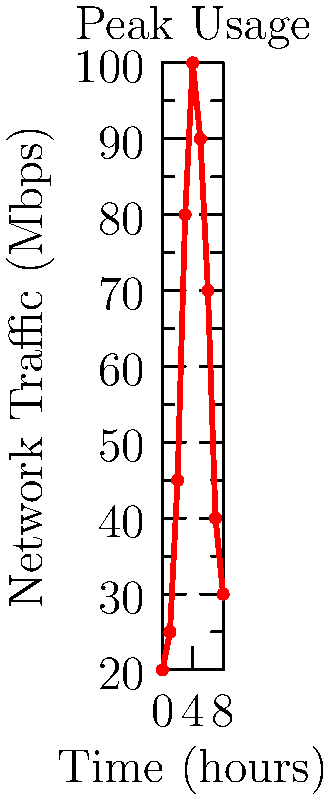Based on the network traffic flow chart for Moodle usage, at which hour does the peak traffic occur, and what strategy would you implement to optimize Moodle's performance during this time? To answer this question, let's analyze the graph step-by-step:

1. Observe the x-axis: It represents time in hours, from 0 to 8.
2. Observe the y-axis: It represents network traffic in Mbps.
3. Analyze the curve: The traffic increases from the start, reaches a peak, and then decreases.
4. Identify the peak: The highest point on the curve occurs at x = 4 (4 hours from the start) and y ≈ 100 Mbps.

Now, to optimize Moodle's performance during this peak time:

1. Implement load balancing: Distribute incoming traffic across multiple servers to prevent any single server from becoming overwhelmed.
2. Use caching mechanisms: Implement server-side and client-side caching to reduce the load on the database and improve response times.
3. Optimize database queries: Ensure that all database queries are efficient and properly indexed to handle the increased load.
4. Content Delivery Network (CDN): Use a CDN to serve static content, reducing the load on the Moodle servers.
5. Increase server resources: Temporarily allocate more CPU, RAM, or bandwidth to the Moodle servers during this peak time.

The most effective strategy would be to implement load balancing, as it directly addresses the issue of high traffic by distributing it across multiple servers, ensuring better performance and reliability during peak usage.
Answer: Peak occurs at hour 4; implement load balancing. 